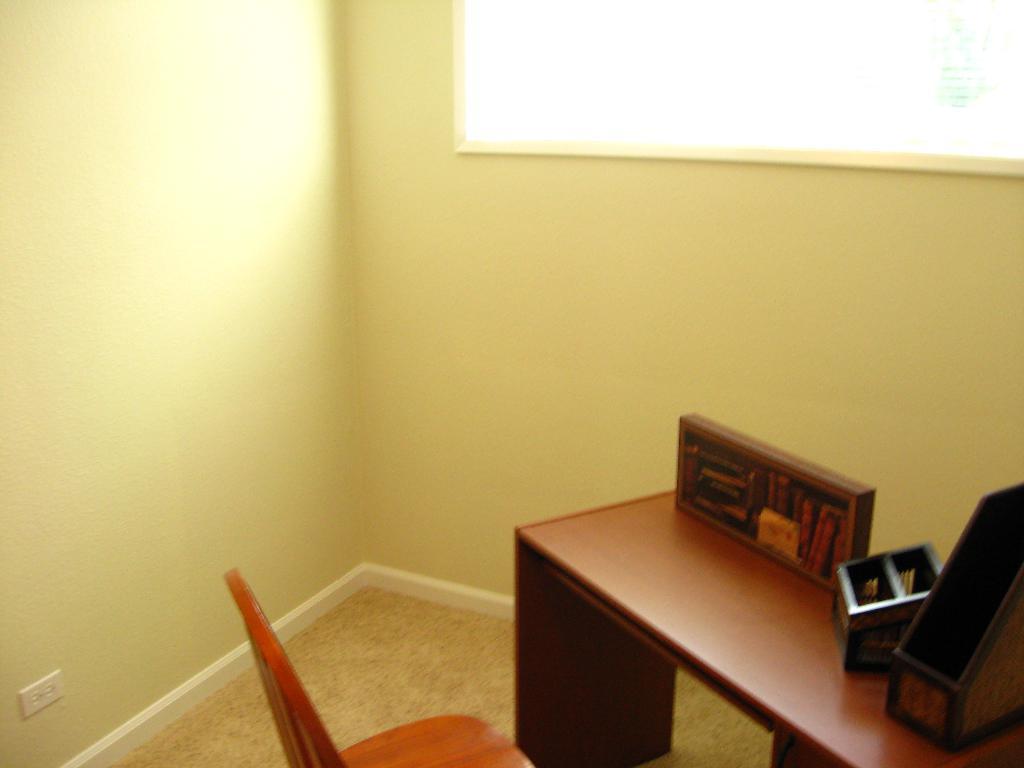How would you summarize this image in a sentence or two? This picture is clicked inside the room. In the foreground there is a wooden chair and a table on the top of which some items are placed. In the background we can see the wall and the window and the ground. 